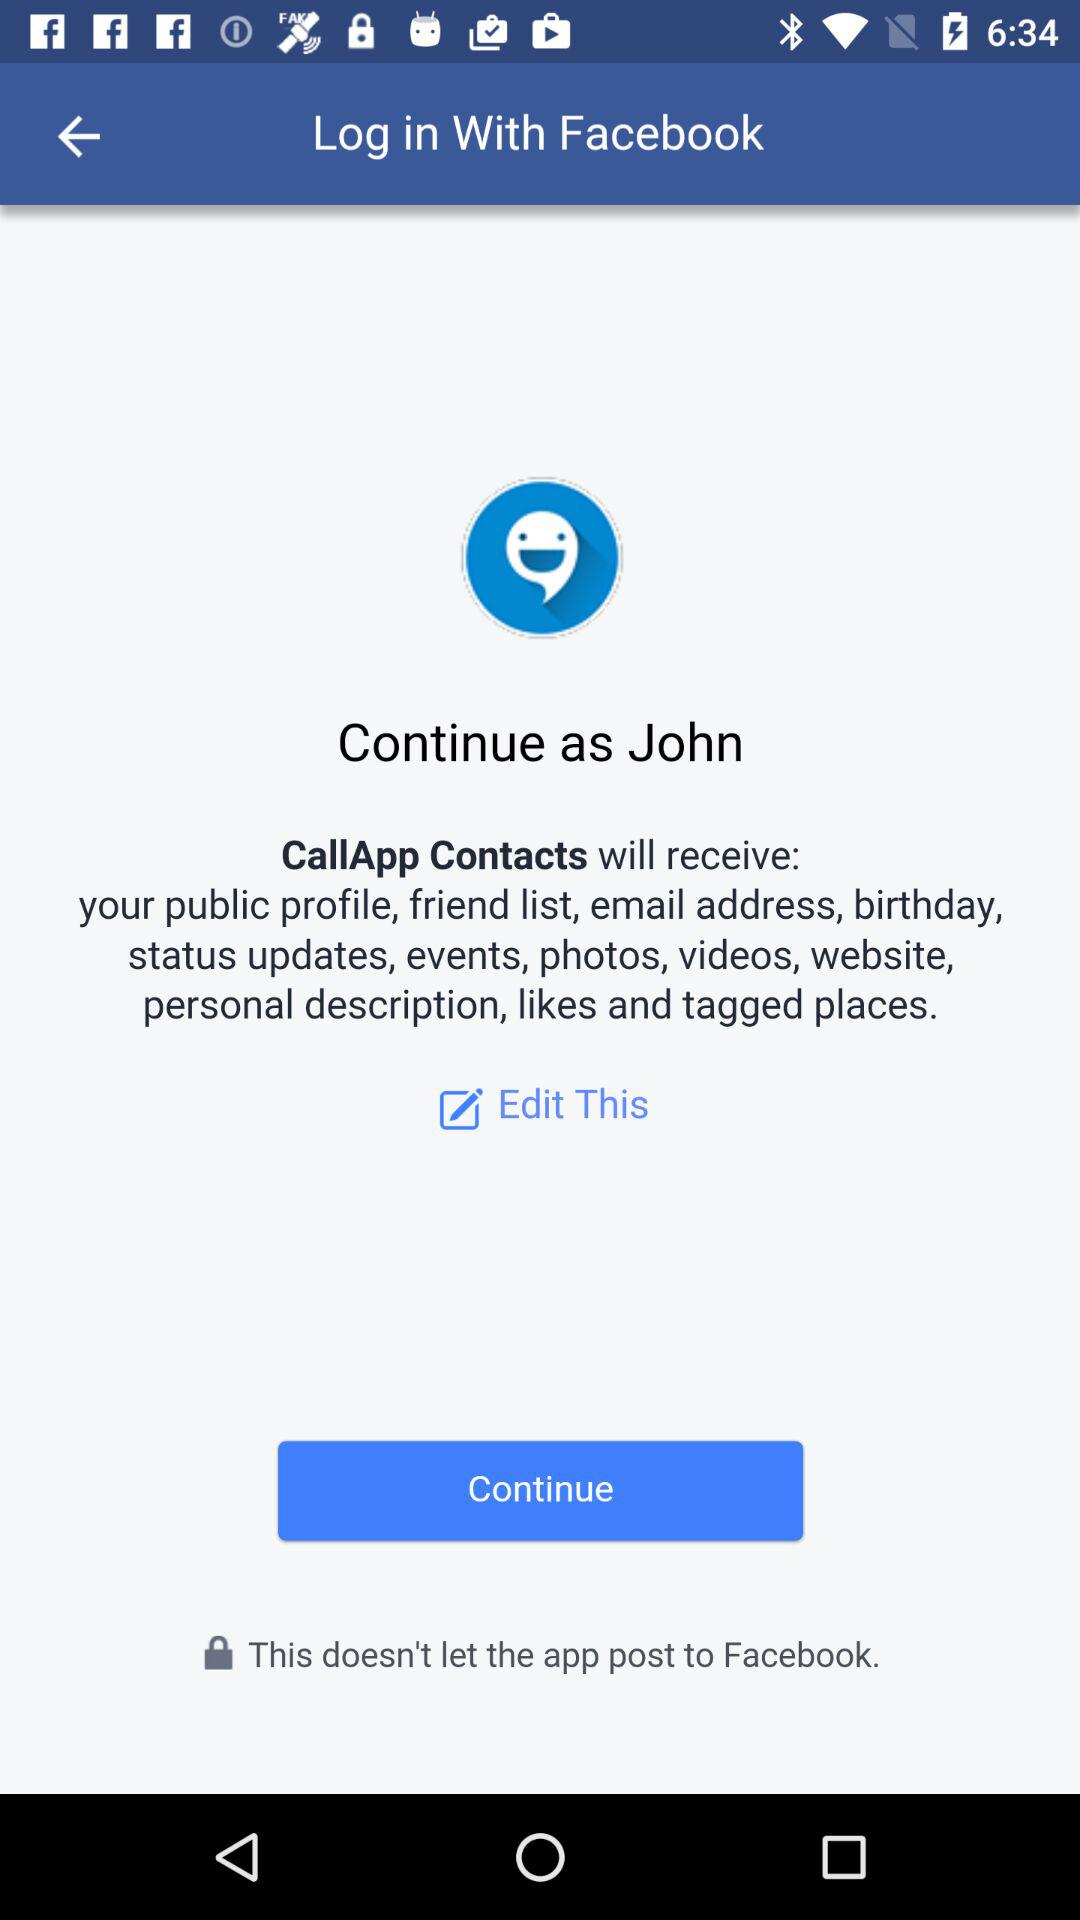Through which application can we log in? You can log in through "Facebook". 